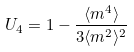Convert formula to latex. <formula><loc_0><loc_0><loc_500><loc_500>U _ { 4 } = 1 - \frac { \langle m ^ { 4 } \rangle } { 3 \langle m ^ { 2 } \rangle ^ { 2 } }</formula> 